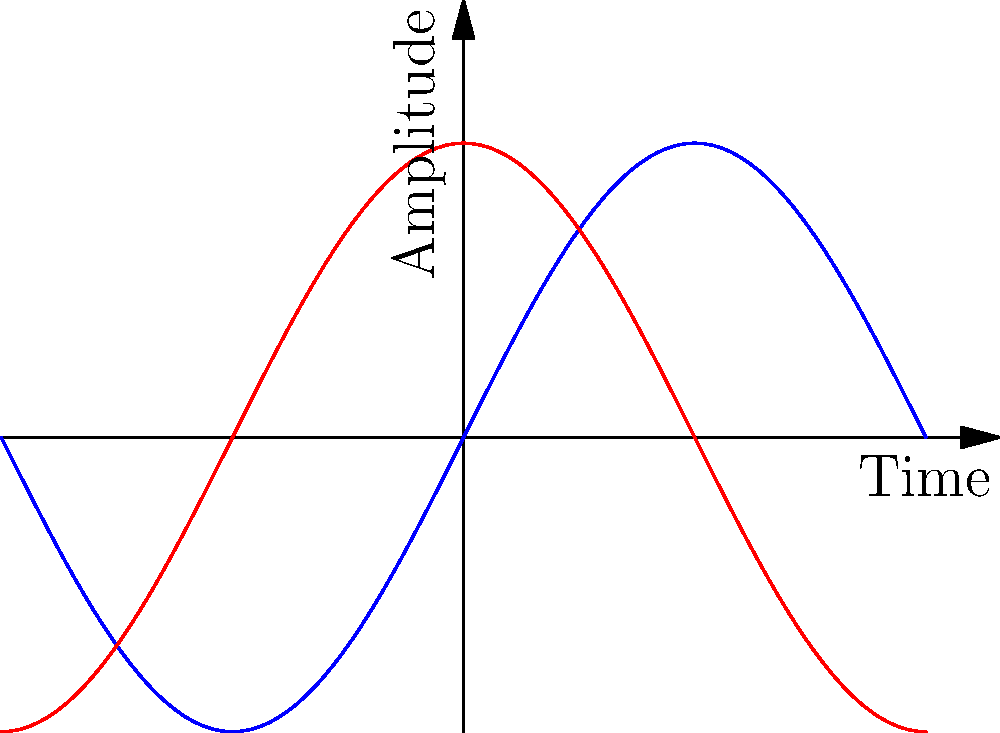In the context of anxiety-relieving breathing exercises, how does the simple harmonic motion principle relate to the rhythm of inhalation and exhalation? Explain using the graph, where the blue curve represents position (chest expansion) and the red curve represents velocity (rate of breathing). To understand how simple harmonic motion relates to anxiety-relieving breathing exercises, let's analyze the graph step-by-step:

1. The blue curve (position) represents chest expansion:
   - Peaks indicate maximum inhalation
   - Troughs indicate maximum exhalation
   - The sinusoidal shape shows smooth transitions between inhalation and exhalation

2. The red curve (velocity) represents the rate of breathing:
   - Positive values indicate inhalation (chest expanding)
   - Negative values indicate exhalation (chest contracting)
   - Zero-crossings indicate moments of full inhalation or exhalation

3. Relationship between position and velocity:
   - When position (blue) is at its maximum or minimum, velocity (red) is zero
   - When position (blue) crosses the midpoint, velocity (red) is at its maximum or minimum

4. Application to anxiety-relieving breathing:
   - The smooth, rhythmic pattern mimics controlled breathing techniques
   - Equal time spent on inhalation and exhalation promotes balance
   - The gradual increase and decrease in breathing rate helps maintain a calm, steady rhythm

5. Mental health app integration:
   - The app could use this principle to guide users through breathing exercises
   - Visual or auditory cues based on the sinusoidal pattern can help users maintain a steady breathing rhythm
   - The app can adjust the frequency (period) of the cycle to match different breathing techniques or user preferences

By applying the principles of simple harmonic motion to breathing exercises, the mental health app can provide a scientifically-based, calming experience for users managing anxiety.
Answer: Simple harmonic motion provides a balanced, rhythmic pattern for controlled breathing, alternating smoothly between inhalation and exhalation, which can be visualized and guided by a mental health app to reduce anxiety. 